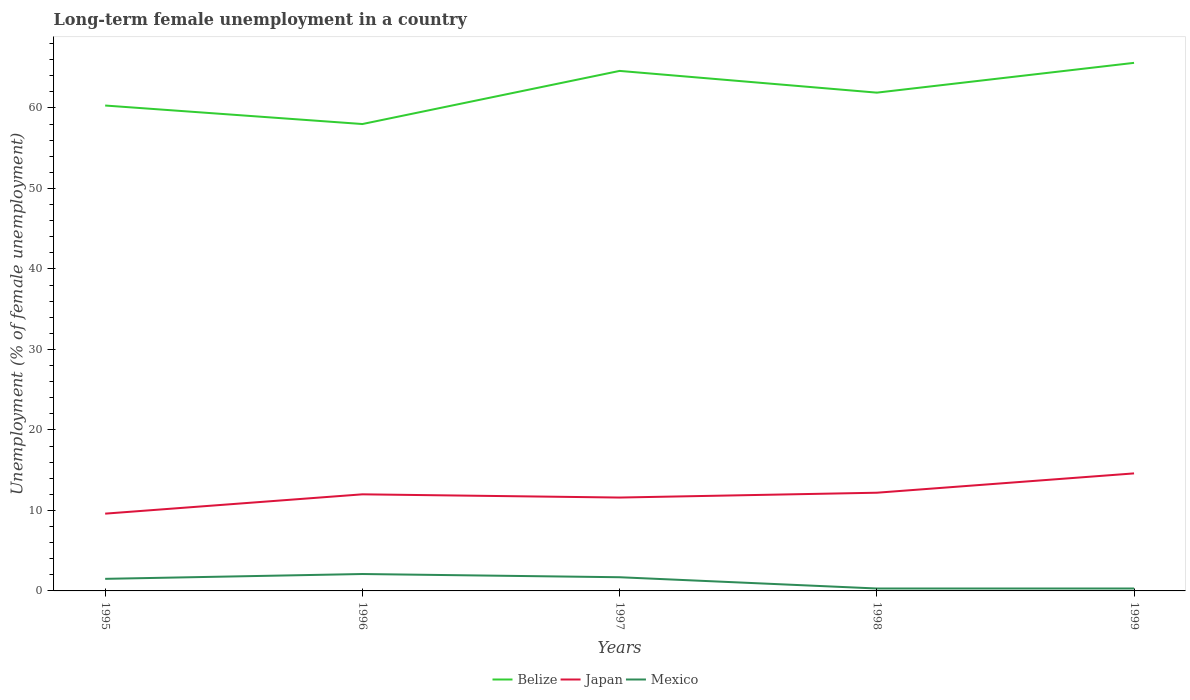Is the number of lines equal to the number of legend labels?
Keep it short and to the point. Yes. Across all years, what is the maximum percentage of long-term unemployed female population in Belize?
Keep it short and to the point. 58. What is the total percentage of long-term unemployed female population in Belize in the graph?
Ensure brevity in your answer.  2.7. What is the difference between the highest and the second highest percentage of long-term unemployed female population in Belize?
Offer a very short reply. 7.6. What is the difference between the highest and the lowest percentage of long-term unemployed female population in Belize?
Provide a short and direct response. 2. Is the percentage of long-term unemployed female population in Japan strictly greater than the percentage of long-term unemployed female population in Mexico over the years?
Make the answer very short. No. How many lines are there?
Offer a terse response. 3. How many years are there in the graph?
Provide a succinct answer. 5. Are the values on the major ticks of Y-axis written in scientific E-notation?
Ensure brevity in your answer.  No. How many legend labels are there?
Your answer should be compact. 3. What is the title of the graph?
Provide a succinct answer. Long-term female unemployment in a country. What is the label or title of the X-axis?
Ensure brevity in your answer.  Years. What is the label or title of the Y-axis?
Keep it short and to the point. Unemployment (% of female unemployment). What is the Unemployment (% of female unemployment) of Belize in 1995?
Give a very brief answer. 60.3. What is the Unemployment (% of female unemployment) in Japan in 1995?
Give a very brief answer. 9.6. What is the Unemployment (% of female unemployment) of Japan in 1996?
Offer a very short reply. 12. What is the Unemployment (% of female unemployment) in Mexico in 1996?
Your response must be concise. 2.1. What is the Unemployment (% of female unemployment) in Belize in 1997?
Your answer should be very brief. 64.6. What is the Unemployment (% of female unemployment) of Japan in 1997?
Give a very brief answer. 11.6. What is the Unemployment (% of female unemployment) of Mexico in 1997?
Offer a very short reply. 1.7. What is the Unemployment (% of female unemployment) of Belize in 1998?
Your answer should be compact. 61.9. What is the Unemployment (% of female unemployment) in Japan in 1998?
Provide a succinct answer. 12.2. What is the Unemployment (% of female unemployment) of Mexico in 1998?
Your answer should be compact. 0.3. What is the Unemployment (% of female unemployment) of Belize in 1999?
Offer a terse response. 65.6. What is the Unemployment (% of female unemployment) in Japan in 1999?
Your answer should be very brief. 14.6. What is the Unemployment (% of female unemployment) in Mexico in 1999?
Ensure brevity in your answer.  0.3. Across all years, what is the maximum Unemployment (% of female unemployment) of Belize?
Your answer should be very brief. 65.6. Across all years, what is the maximum Unemployment (% of female unemployment) of Japan?
Keep it short and to the point. 14.6. Across all years, what is the maximum Unemployment (% of female unemployment) in Mexico?
Provide a succinct answer. 2.1. Across all years, what is the minimum Unemployment (% of female unemployment) in Belize?
Your response must be concise. 58. Across all years, what is the minimum Unemployment (% of female unemployment) in Japan?
Ensure brevity in your answer.  9.6. Across all years, what is the minimum Unemployment (% of female unemployment) of Mexico?
Ensure brevity in your answer.  0.3. What is the total Unemployment (% of female unemployment) of Belize in the graph?
Offer a terse response. 310.4. What is the total Unemployment (% of female unemployment) of Japan in the graph?
Offer a terse response. 60. What is the difference between the Unemployment (% of female unemployment) of Mexico in 1995 and that in 1996?
Your answer should be very brief. -0.6. What is the difference between the Unemployment (% of female unemployment) of Japan in 1995 and that in 1997?
Provide a succinct answer. -2. What is the difference between the Unemployment (% of female unemployment) in Belize in 1995 and that in 1998?
Offer a very short reply. -1.6. What is the difference between the Unemployment (% of female unemployment) of Japan in 1995 and that in 1998?
Ensure brevity in your answer.  -2.6. What is the difference between the Unemployment (% of female unemployment) in Mexico in 1995 and that in 1998?
Give a very brief answer. 1.2. What is the difference between the Unemployment (% of female unemployment) of Japan in 1995 and that in 1999?
Your answer should be very brief. -5. What is the difference between the Unemployment (% of female unemployment) in Mexico in 1996 and that in 1997?
Ensure brevity in your answer.  0.4. What is the difference between the Unemployment (% of female unemployment) in Belize in 1996 and that in 1998?
Your answer should be very brief. -3.9. What is the difference between the Unemployment (% of female unemployment) in Japan in 1996 and that in 1998?
Make the answer very short. -0.2. What is the difference between the Unemployment (% of female unemployment) of Mexico in 1996 and that in 1998?
Make the answer very short. 1.8. What is the difference between the Unemployment (% of female unemployment) in Belize in 1996 and that in 1999?
Your response must be concise. -7.6. What is the difference between the Unemployment (% of female unemployment) of Belize in 1997 and that in 1998?
Your answer should be compact. 2.7. What is the difference between the Unemployment (% of female unemployment) of Mexico in 1997 and that in 1998?
Keep it short and to the point. 1.4. What is the difference between the Unemployment (% of female unemployment) of Japan in 1997 and that in 1999?
Make the answer very short. -3. What is the difference between the Unemployment (% of female unemployment) of Mexico in 1997 and that in 1999?
Your answer should be compact. 1.4. What is the difference between the Unemployment (% of female unemployment) in Belize in 1998 and that in 1999?
Offer a very short reply. -3.7. What is the difference between the Unemployment (% of female unemployment) of Japan in 1998 and that in 1999?
Keep it short and to the point. -2.4. What is the difference between the Unemployment (% of female unemployment) of Mexico in 1998 and that in 1999?
Your response must be concise. 0. What is the difference between the Unemployment (% of female unemployment) in Belize in 1995 and the Unemployment (% of female unemployment) in Japan in 1996?
Offer a very short reply. 48.3. What is the difference between the Unemployment (% of female unemployment) in Belize in 1995 and the Unemployment (% of female unemployment) in Mexico in 1996?
Ensure brevity in your answer.  58.2. What is the difference between the Unemployment (% of female unemployment) of Belize in 1995 and the Unemployment (% of female unemployment) of Japan in 1997?
Your answer should be compact. 48.7. What is the difference between the Unemployment (% of female unemployment) in Belize in 1995 and the Unemployment (% of female unemployment) in Mexico in 1997?
Provide a succinct answer. 58.6. What is the difference between the Unemployment (% of female unemployment) of Japan in 1995 and the Unemployment (% of female unemployment) of Mexico in 1997?
Keep it short and to the point. 7.9. What is the difference between the Unemployment (% of female unemployment) of Belize in 1995 and the Unemployment (% of female unemployment) of Japan in 1998?
Your answer should be compact. 48.1. What is the difference between the Unemployment (% of female unemployment) in Belize in 1995 and the Unemployment (% of female unemployment) in Mexico in 1998?
Provide a short and direct response. 60. What is the difference between the Unemployment (% of female unemployment) in Japan in 1995 and the Unemployment (% of female unemployment) in Mexico in 1998?
Provide a short and direct response. 9.3. What is the difference between the Unemployment (% of female unemployment) of Belize in 1995 and the Unemployment (% of female unemployment) of Japan in 1999?
Keep it short and to the point. 45.7. What is the difference between the Unemployment (% of female unemployment) of Japan in 1995 and the Unemployment (% of female unemployment) of Mexico in 1999?
Your answer should be compact. 9.3. What is the difference between the Unemployment (% of female unemployment) of Belize in 1996 and the Unemployment (% of female unemployment) of Japan in 1997?
Your answer should be compact. 46.4. What is the difference between the Unemployment (% of female unemployment) of Belize in 1996 and the Unemployment (% of female unemployment) of Mexico in 1997?
Make the answer very short. 56.3. What is the difference between the Unemployment (% of female unemployment) of Belize in 1996 and the Unemployment (% of female unemployment) of Japan in 1998?
Make the answer very short. 45.8. What is the difference between the Unemployment (% of female unemployment) of Belize in 1996 and the Unemployment (% of female unemployment) of Mexico in 1998?
Provide a succinct answer. 57.7. What is the difference between the Unemployment (% of female unemployment) of Japan in 1996 and the Unemployment (% of female unemployment) of Mexico in 1998?
Provide a short and direct response. 11.7. What is the difference between the Unemployment (% of female unemployment) of Belize in 1996 and the Unemployment (% of female unemployment) of Japan in 1999?
Your answer should be compact. 43.4. What is the difference between the Unemployment (% of female unemployment) in Belize in 1996 and the Unemployment (% of female unemployment) in Mexico in 1999?
Make the answer very short. 57.7. What is the difference between the Unemployment (% of female unemployment) of Japan in 1996 and the Unemployment (% of female unemployment) of Mexico in 1999?
Ensure brevity in your answer.  11.7. What is the difference between the Unemployment (% of female unemployment) of Belize in 1997 and the Unemployment (% of female unemployment) of Japan in 1998?
Your answer should be very brief. 52.4. What is the difference between the Unemployment (% of female unemployment) of Belize in 1997 and the Unemployment (% of female unemployment) of Mexico in 1998?
Offer a terse response. 64.3. What is the difference between the Unemployment (% of female unemployment) in Belize in 1997 and the Unemployment (% of female unemployment) in Mexico in 1999?
Provide a succinct answer. 64.3. What is the difference between the Unemployment (% of female unemployment) in Japan in 1997 and the Unemployment (% of female unemployment) in Mexico in 1999?
Provide a succinct answer. 11.3. What is the difference between the Unemployment (% of female unemployment) of Belize in 1998 and the Unemployment (% of female unemployment) of Japan in 1999?
Make the answer very short. 47.3. What is the difference between the Unemployment (% of female unemployment) of Belize in 1998 and the Unemployment (% of female unemployment) of Mexico in 1999?
Ensure brevity in your answer.  61.6. What is the average Unemployment (% of female unemployment) in Belize per year?
Offer a very short reply. 62.08. What is the average Unemployment (% of female unemployment) in Mexico per year?
Your response must be concise. 1.18. In the year 1995, what is the difference between the Unemployment (% of female unemployment) of Belize and Unemployment (% of female unemployment) of Japan?
Offer a terse response. 50.7. In the year 1995, what is the difference between the Unemployment (% of female unemployment) of Belize and Unemployment (% of female unemployment) of Mexico?
Your answer should be very brief. 58.8. In the year 1996, what is the difference between the Unemployment (% of female unemployment) of Belize and Unemployment (% of female unemployment) of Mexico?
Make the answer very short. 55.9. In the year 1996, what is the difference between the Unemployment (% of female unemployment) in Japan and Unemployment (% of female unemployment) in Mexico?
Provide a short and direct response. 9.9. In the year 1997, what is the difference between the Unemployment (% of female unemployment) of Belize and Unemployment (% of female unemployment) of Japan?
Ensure brevity in your answer.  53. In the year 1997, what is the difference between the Unemployment (% of female unemployment) in Belize and Unemployment (% of female unemployment) in Mexico?
Keep it short and to the point. 62.9. In the year 1997, what is the difference between the Unemployment (% of female unemployment) of Japan and Unemployment (% of female unemployment) of Mexico?
Offer a very short reply. 9.9. In the year 1998, what is the difference between the Unemployment (% of female unemployment) in Belize and Unemployment (% of female unemployment) in Japan?
Provide a short and direct response. 49.7. In the year 1998, what is the difference between the Unemployment (% of female unemployment) of Belize and Unemployment (% of female unemployment) of Mexico?
Give a very brief answer. 61.6. In the year 1999, what is the difference between the Unemployment (% of female unemployment) in Belize and Unemployment (% of female unemployment) in Japan?
Ensure brevity in your answer.  51. In the year 1999, what is the difference between the Unemployment (% of female unemployment) in Belize and Unemployment (% of female unemployment) in Mexico?
Offer a very short reply. 65.3. What is the ratio of the Unemployment (% of female unemployment) in Belize in 1995 to that in 1996?
Give a very brief answer. 1.04. What is the ratio of the Unemployment (% of female unemployment) in Mexico in 1995 to that in 1996?
Offer a terse response. 0.71. What is the ratio of the Unemployment (% of female unemployment) of Belize in 1995 to that in 1997?
Offer a terse response. 0.93. What is the ratio of the Unemployment (% of female unemployment) in Japan in 1995 to that in 1997?
Your answer should be very brief. 0.83. What is the ratio of the Unemployment (% of female unemployment) in Mexico in 1995 to that in 1997?
Your response must be concise. 0.88. What is the ratio of the Unemployment (% of female unemployment) in Belize in 1995 to that in 1998?
Give a very brief answer. 0.97. What is the ratio of the Unemployment (% of female unemployment) of Japan in 1995 to that in 1998?
Provide a short and direct response. 0.79. What is the ratio of the Unemployment (% of female unemployment) of Belize in 1995 to that in 1999?
Give a very brief answer. 0.92. What is the ratio of the Unemployment (% of female unemployment) of Japan in 1995 to that in 1999?
Give a very brief answer. 0.66. What is the ratio of the Unemployment (% of female unemployment) in Belize in 1996 to that in 1997?
Make the answer very short. 0.9. What is the ratio of the Unemployment (% of female unemployment) of Japan in 1996 to that in 1997?
Your response must be concise. 1.03. What is the ratio of the Unemployment (% of female unemployment) of Mexico in 1996 to that in 1997?
Provide a short and direct response. 1.24. What is the ratio of the Unemployment (% of female unemployment) of Belize in 1996 to that in 1998?
Provide a short and direct response. 0.94. What is the ratio of the Unemployment (% of female unemployment) of Japan in 1996 to that in 1998?
Give a very brief answer. 0.98. What is the ratio of the Unemployment (% of female unemployment) in Mexico in 1996 to that in 1998?
Your answer should be compact. 7. What is the ratio of the Unemployment (% of female unemployment) in Belize in 1996 to that in 1999?
Give a very brief answer. 0.88. What is the ratio of the Unemployment (% of female unemployment) in Japan in 1996 to that in 1999?
Your response must be concise. 0.82. What is the ratio of the Unemployment (% of female unemployment) of Mexico in 1996 to that in 1999?
Your response must be concise. 7. What is the ratio of the Unemployment (% of female unemployment) of Belize in 1997 to that in 1998?
Make the answer very short. 1.04. What is the ratio of the Unemployment (% of female unemployment) in Japan in 1997 to that in 1998?
Ensure brevity in your answer.  0.95. What is the ratio of the Unemployment (% of female unemployment) of Mexico in 1997 to that in 1998?
Your answer should be very brief. 5.67. What is the ratio of the Unemployment (% of female unemployment) of Japan in 1997 to that in 1999?
Your answer should be compact. 0.79. What is the ratio of the Unemployment (% of female unemployment) of Mexico in 1997 to that in 1999?
Offer a terse response. 5.67. What is the ratio of the Unemployment (% of female unemployment) in Belize in 1998 to that in 1999?
Make the answer very short. 0.94. What is the ratio of the Unemployment (% of female unemployment) of Japan in 1998 to that in 1999?
Your answer should be very brief. 0.84. What is the difference between the highest and the second highest Unemployment (% of female unemployment) of Japan?
Offer a very short reply. 2.4. What is the difference between the highest and the lowest Unemployment (% of female unemployment) of Belize?
Give a very brief answer. 7.6. What is the difference between the highest and the lowest Unemployment (% of female unemployment) of Japan?
Offer a very short reply. 5. What is the difference between the highest and the lowest Unemployment (% of female unemployment) in Mexico?
Make the answer very short. 1.8. 